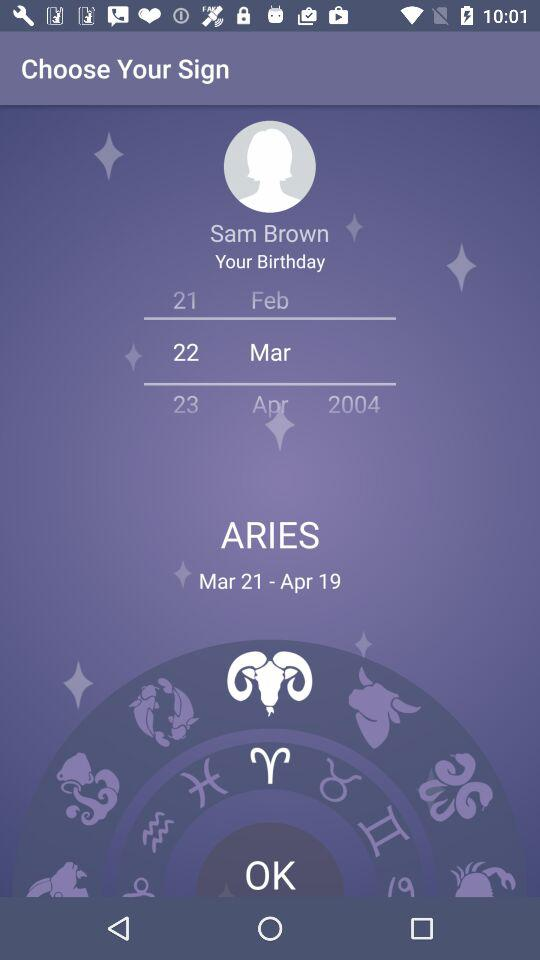What are the months and years of the "ARIES"? The months and years are Mar 21-Apr 19. 